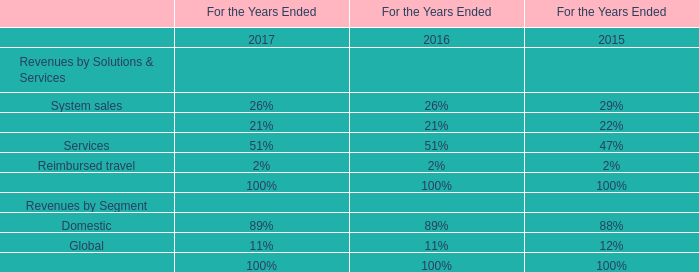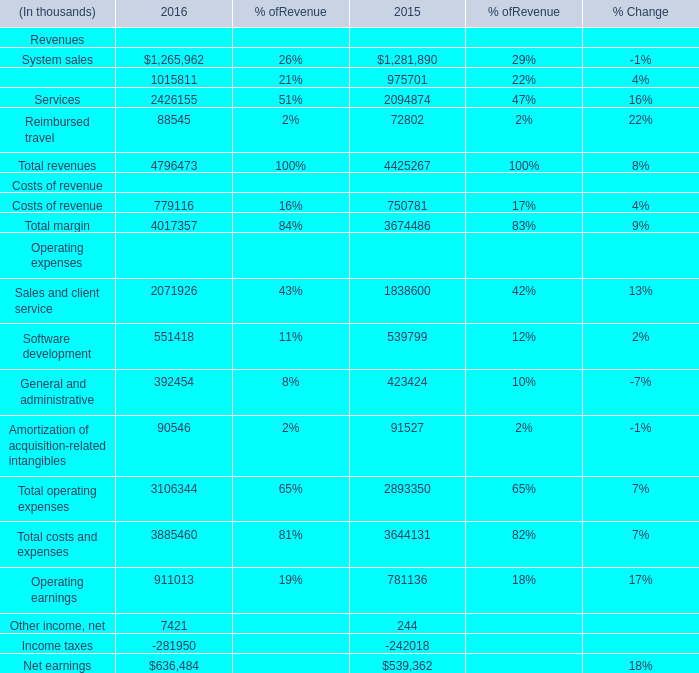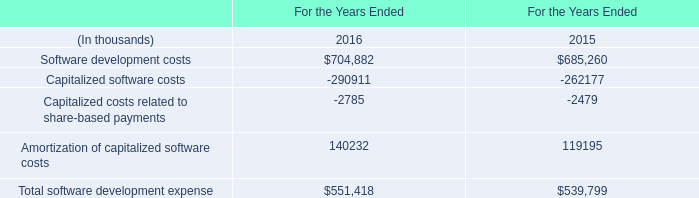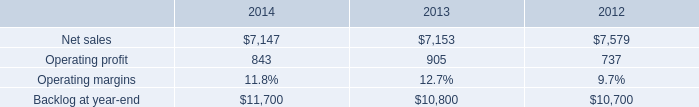what was the percentage change in the backlog from 2013 to 2014 
Computations: ((11700 - 10800) / 10800)
Answer: 0.08333. 